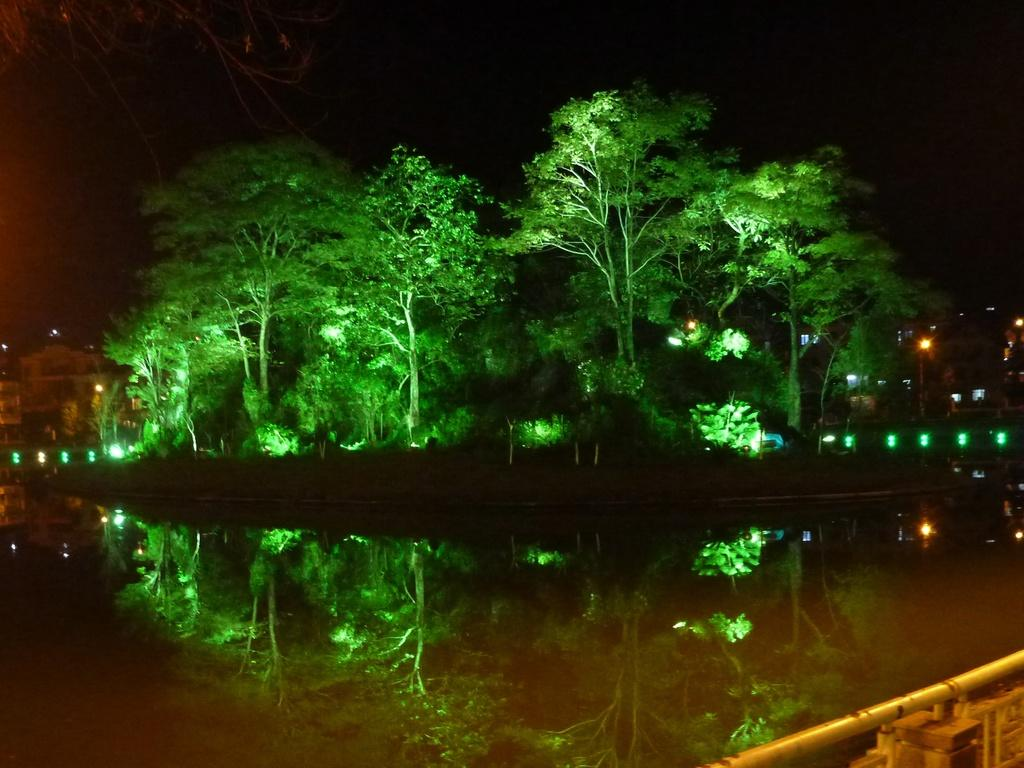What is present in the image that represents a natural element? There is water and trees in the image, which represent natural elements. What artificial elements can be seen in the image? There are lights in the image, which are artificial elements. What is visible in the background of the image? The sky is visible behind the trees in the image. Can you tell me how many dogs are playing in the amusement park in the image? There are no dogs or amusement park present in the image. What role does the porter play in the image? There is no porter present in the image. 